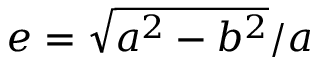<formula> <loc_0><loc_0><loc_500><loc_500>e = \sqrt { a ^ { 2 } - b ^ { 2 } } / a</formula> 